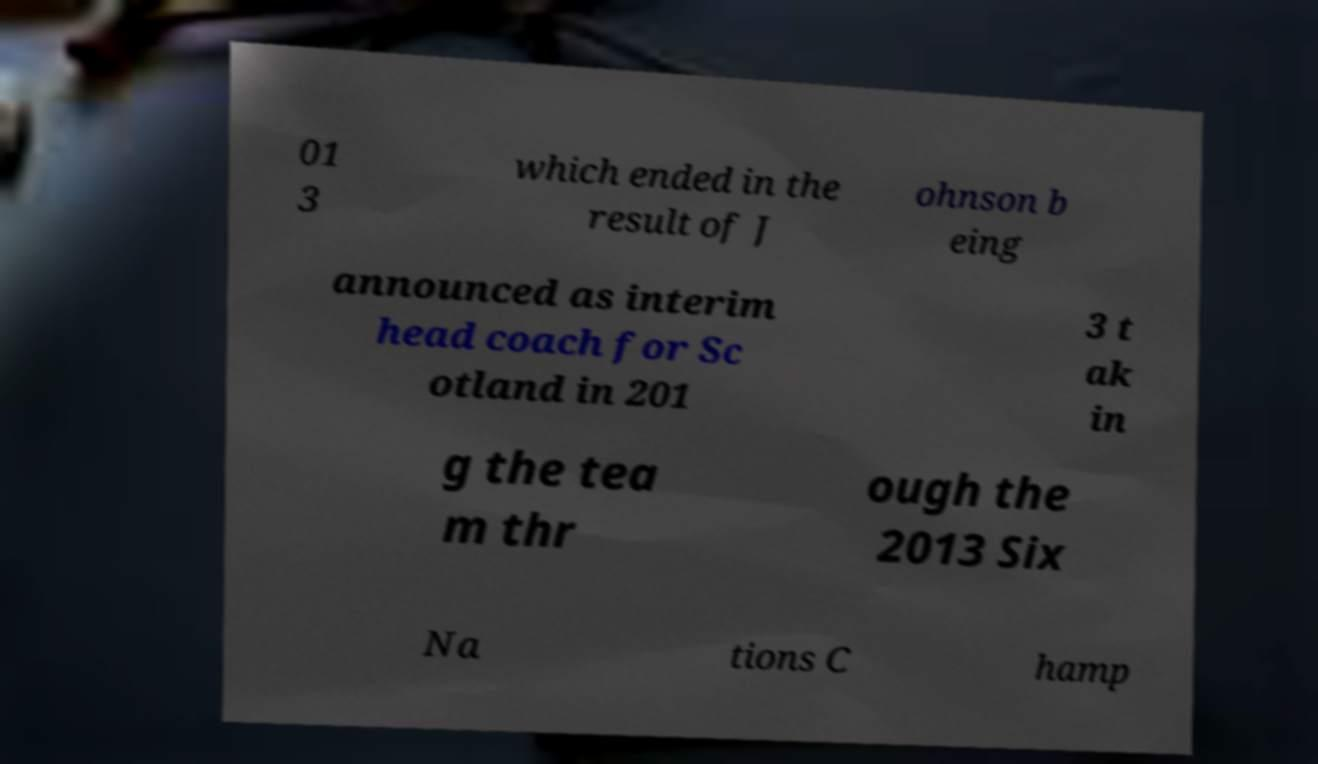Please identify and transcribe the text found in this image. 01 3 which ended in the result of J ohnson b eing announced as interim head coach for Sc otland in 201 3 t ak in g the tea m thr ough the 2013 Six Na tions C hamp 